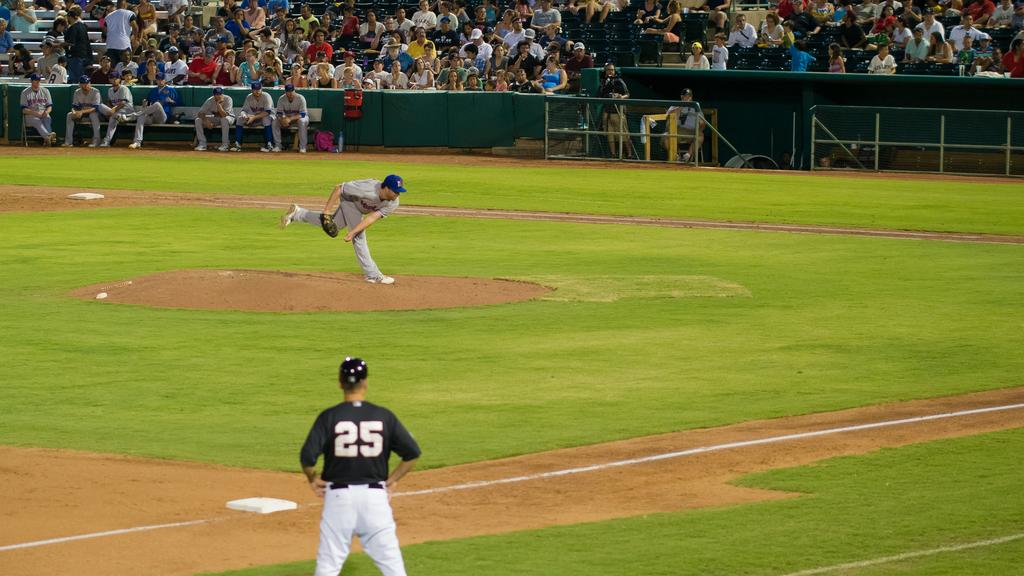Provide a one-sentence caption for the provided image. Number 25 watches the pitcher throw the baseball. 